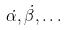<formula> <loc_0><loc_0><loc_500><loc_500>\dot { \alpha } , \dot { \beta } , \dots</formula> 